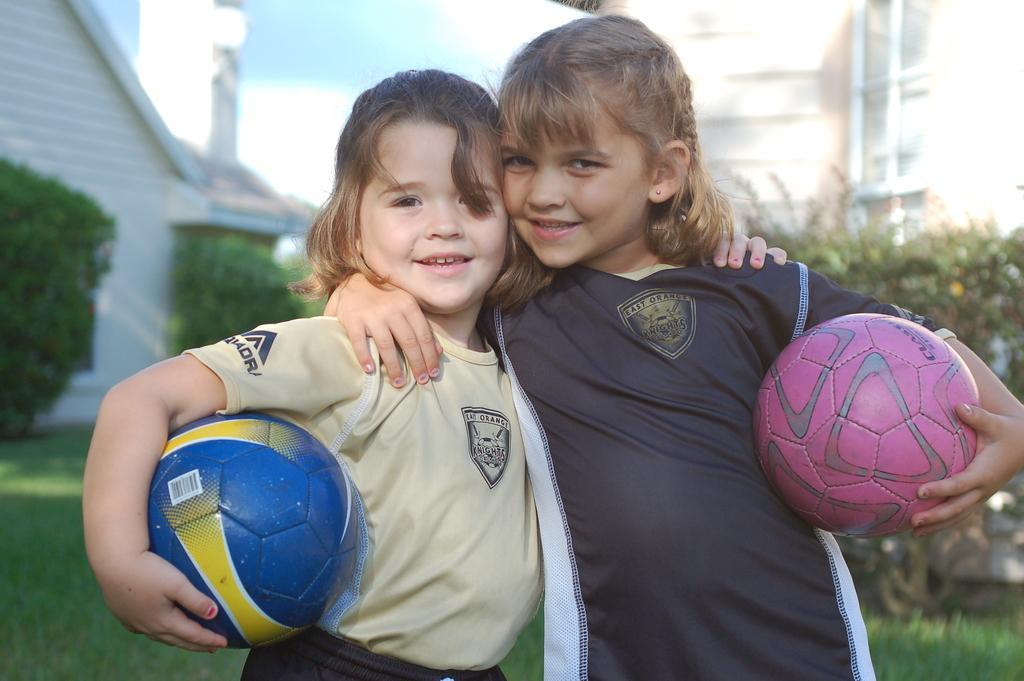Could you give a brief overview of what you see in this image? In the image we can see there are two girls who are standing in front and holding ball in their hand and at the back there are buildings and there are plants in front of them and the ground is covered with grass. 